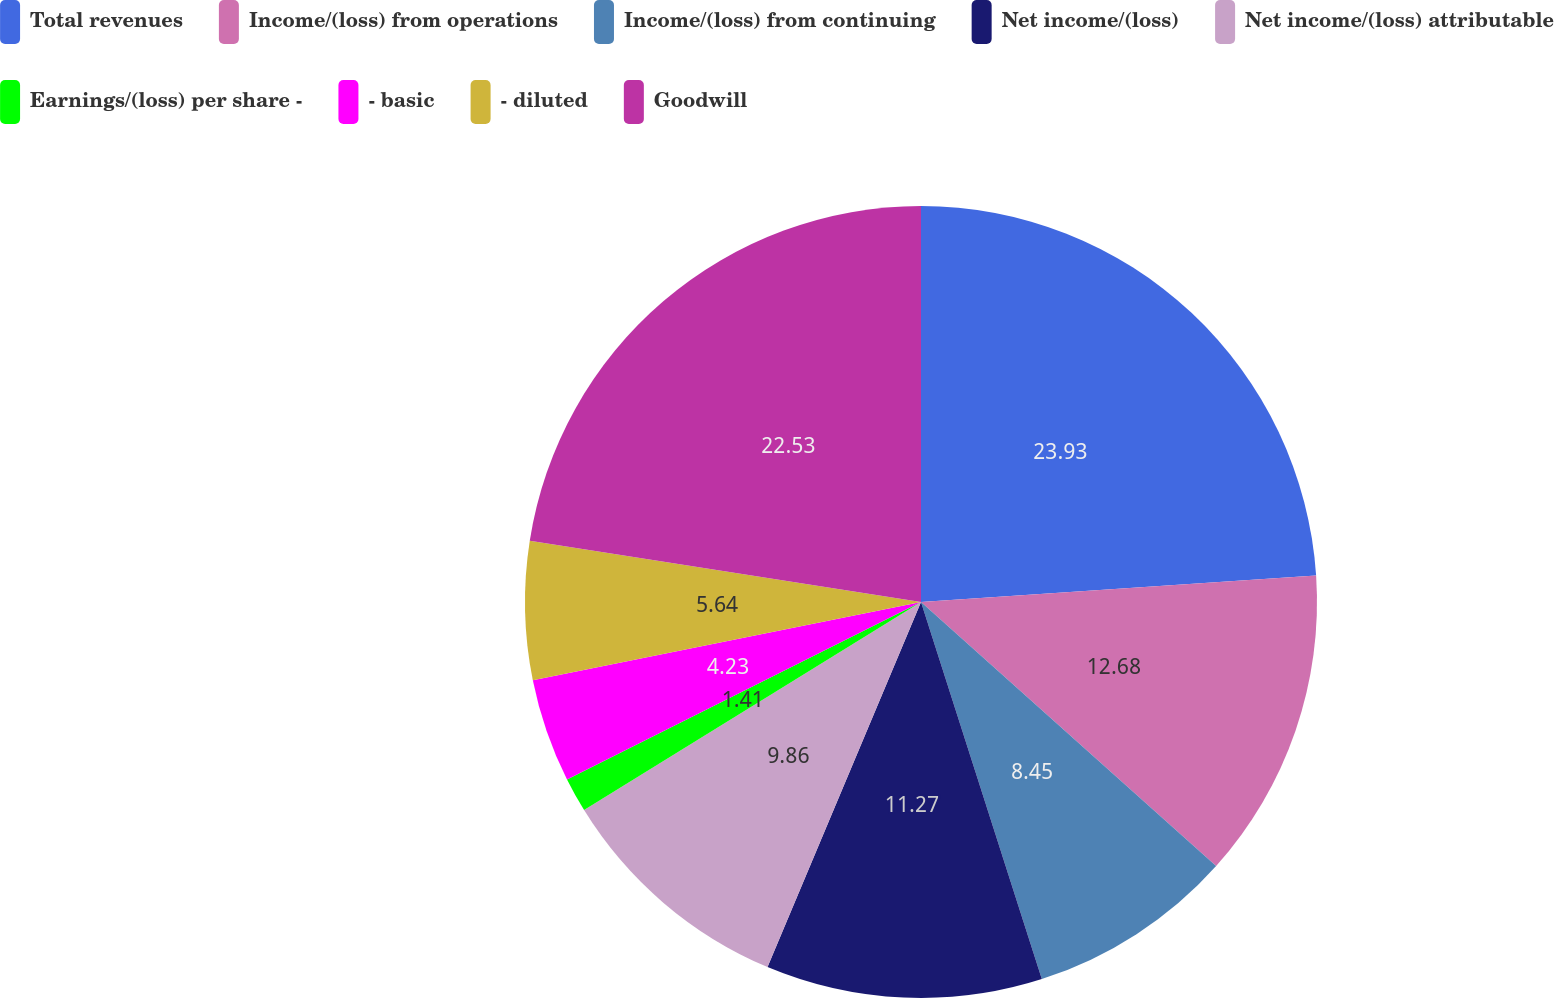Convert chart. <chart><loc_0><loc_0><loc_500><loc_500><pie_chart><fcel>Total revenues<fcel>Income/(loss) from operations<fcel>Income/(loss) from continuing<fcel>Net income/(loss)<fcel>Net income/(loss) attributable<fcel>Earnings/(loss) per share -<fcel>- basic<fcel>- diluted<fcel>Goodwill<nl><fcel>23.94%<fcel>12.68%<fcel>8.45%<fcel>11.27%<fcel>9.86%<fcel>1.41%<fcel>4.23%<fcel>5.64%<fcel>22.53%<nl></chart> 